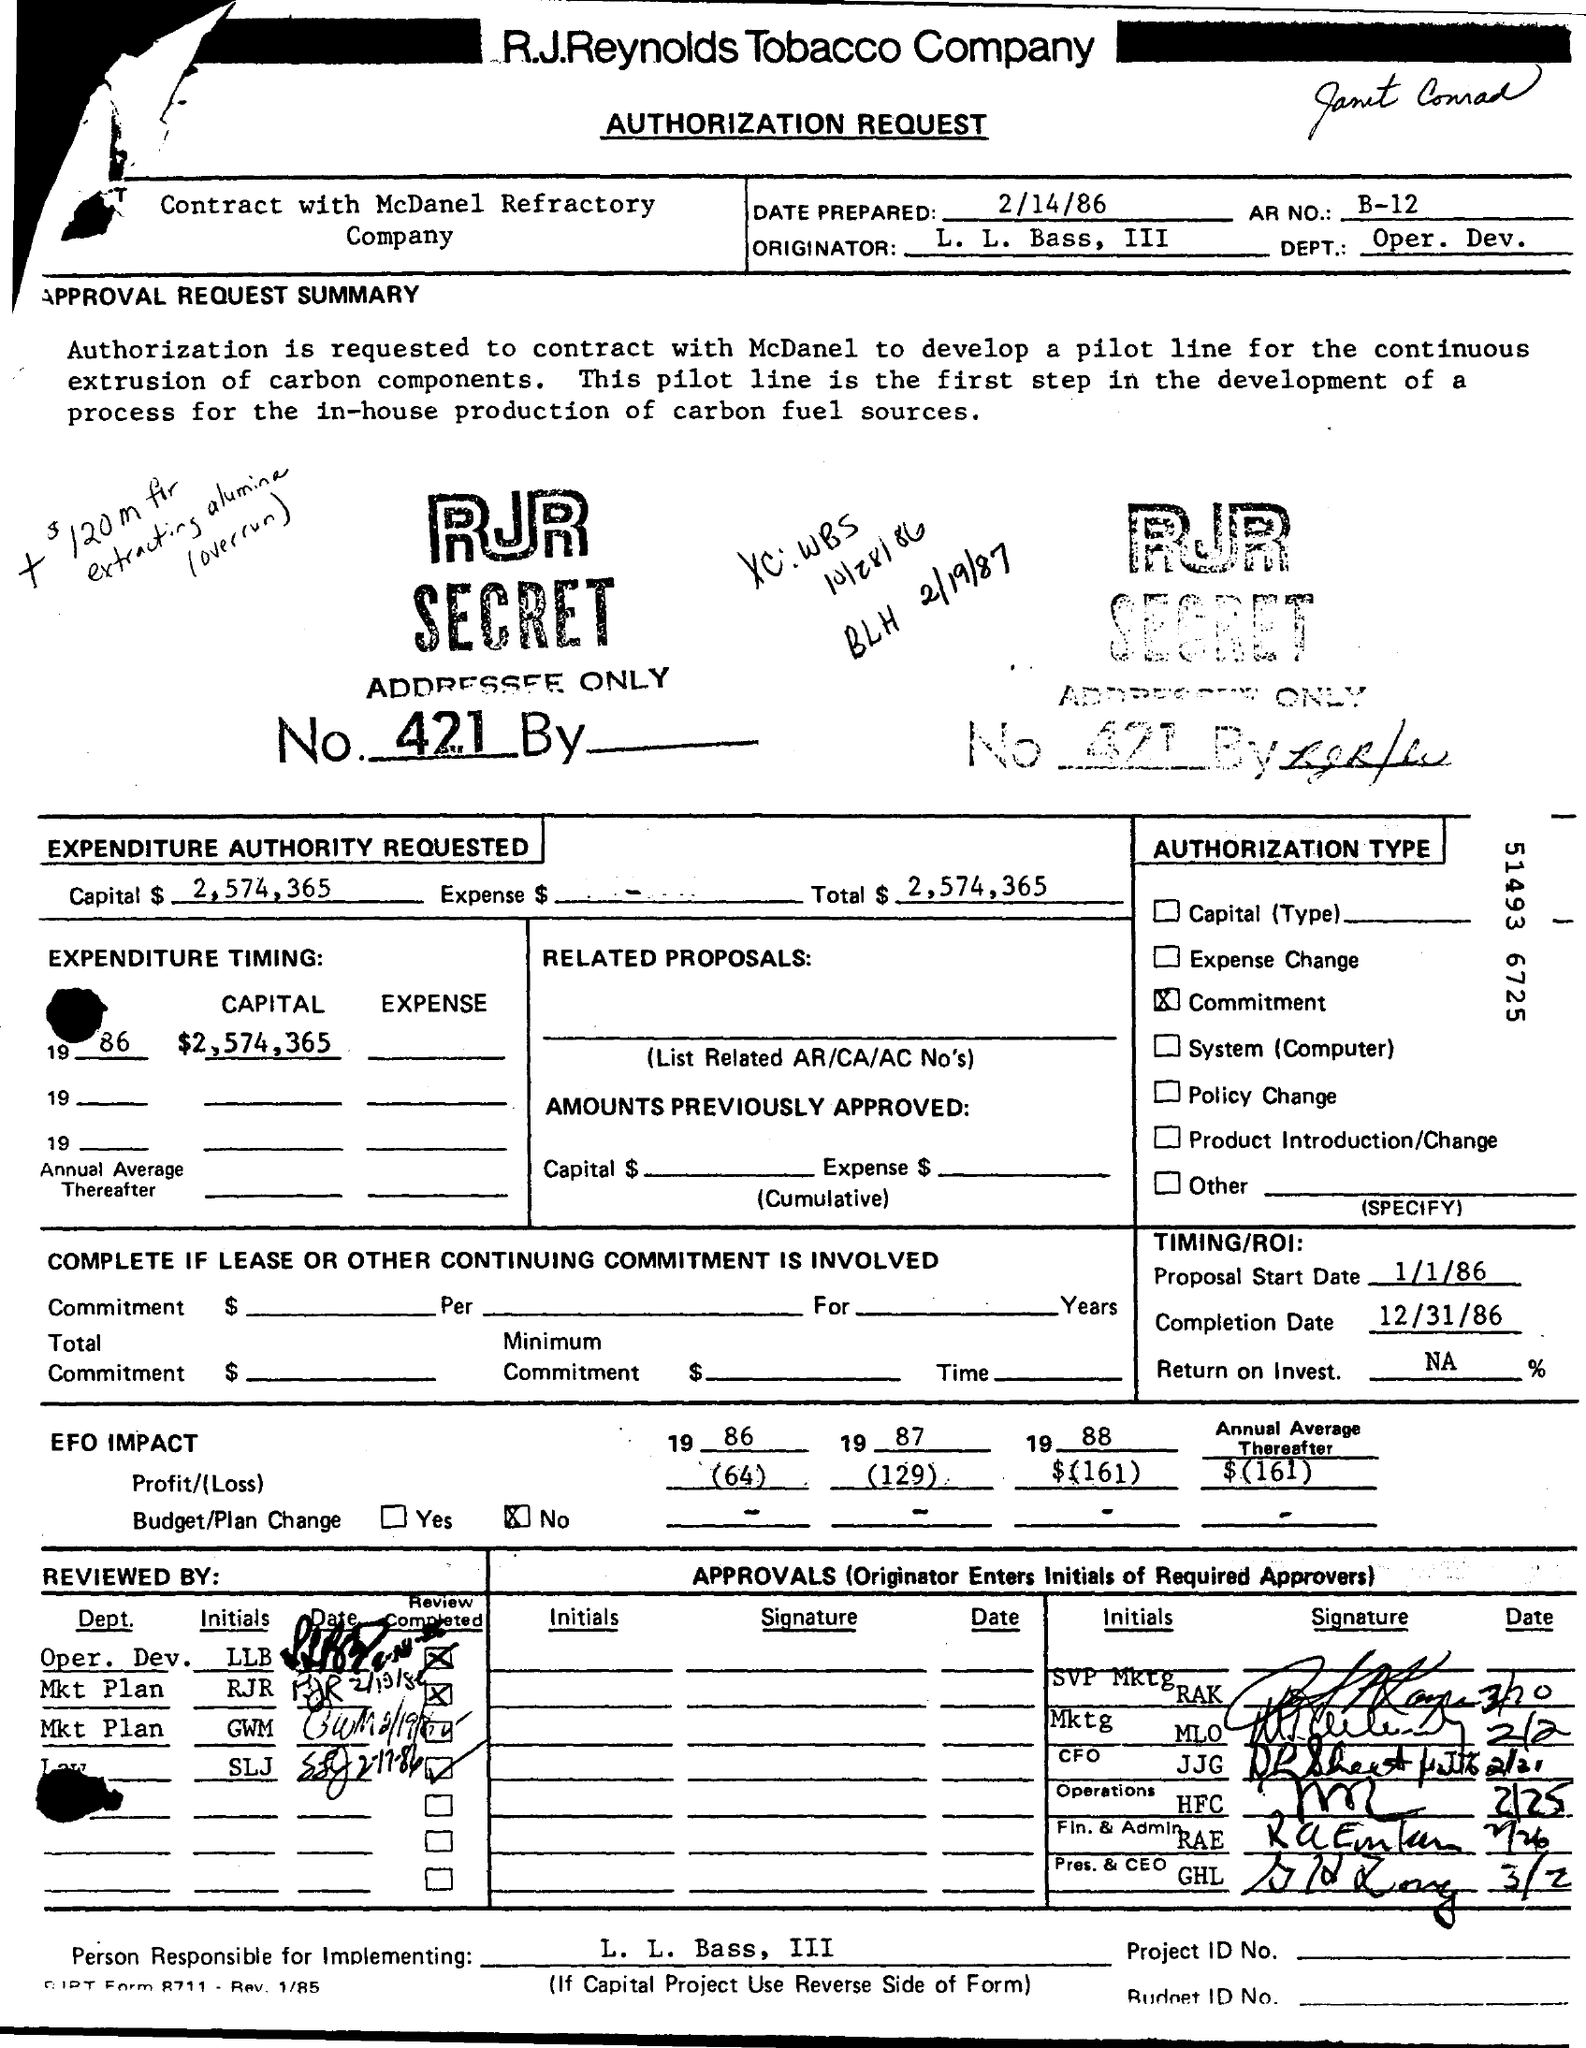What is the total capital amount requested in this authorization form? The total capital amount requested in the authorization form is $2,574,365. This sum is allocated for developing a pilot line, as disclosed in the expenditure details. 